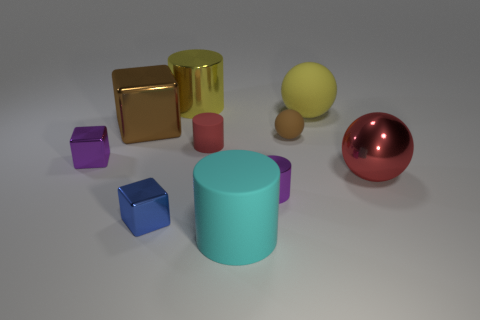Is there a brown thing?
Your response must be concise. Yes. There is a red object that is the same shape as the large cyan matte thing; what material is it?
Provide a succinct answer. Rubber. There is a red thing that is to the right of the cyan rubber cylinder on the right side of the large metallic thing behind the big brown cube; what size is it?
Your response must be concise. Large. There is a large metallic sphere; are there any objects behind it?
Provide a short and direct response. Yes. There is another cylinder that is made of the same material as the tiny purple cylinder; what size is it?
Make the answer very short. Large. What number of other big shiny things are the same shape as the big red metallic thing?
Your response must be concise. 0. Do the big red object and the tiny purple thing that is in front of the red metallic object have the same material?
Your answer should be very brief. Yes. Are there more blue blocks behind the big red object than big red rubber cylinders?
Your response must be concise. No. What shape is the thing that is the same color as the big block?
Offer a very short reply. Sphere. Are there any small purple cylinders that have the same material as the blue object?
Offer a very short reply. Yes. 